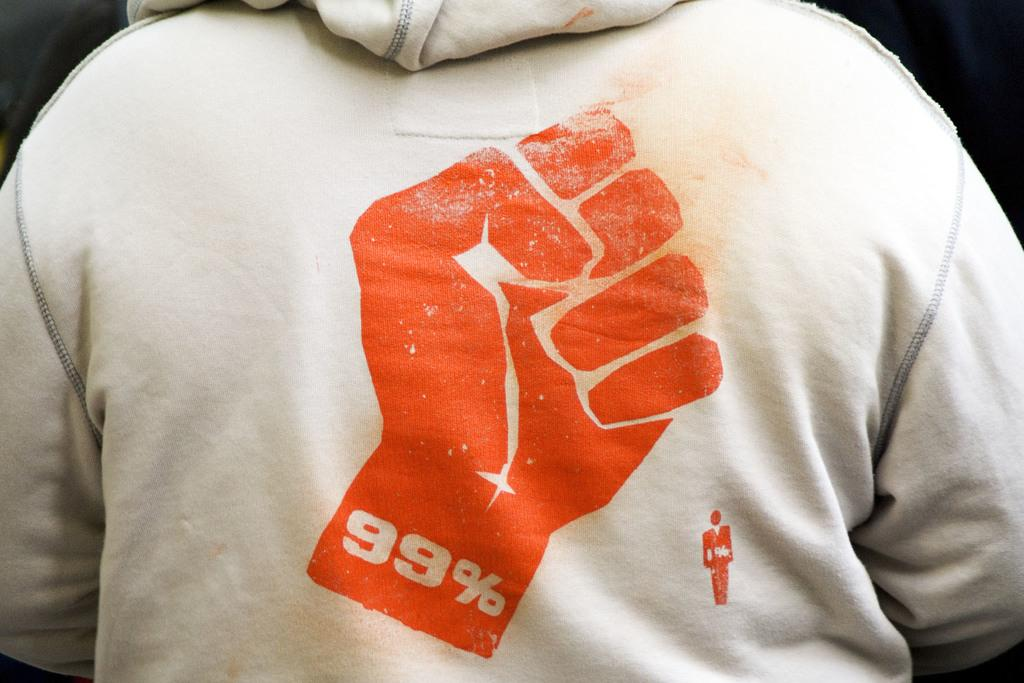What is the main subject in the foreground of the image? There is a person in the foreground of the image. What is the person wearing in the image? The person is wearing a jacket in the image. Is there any specific detail on the jacket? Yes, there is a logo on the jacket. What is the color of the background in the image? The background of the image is black. What is the title of the book the person is holding in the image? There is no book visible in the image, so it is not possible to determine the title. 